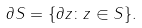<formula> <loc_0><loc_0><loc_500><loc_500>\partial S = \{ \partial z \colon z \in S \} .</formula> 